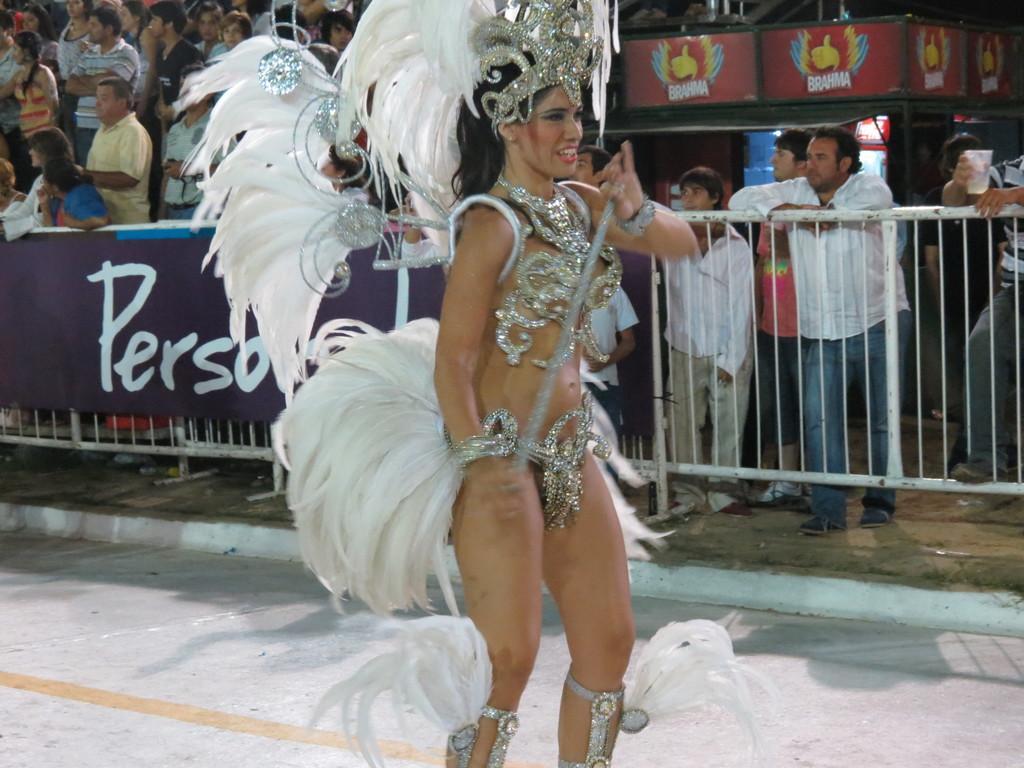In one or two sentences, can you explain what this image depicts? In this image I can see the person standing and the person is wearing white color dress. In the background I can see the board attached to the railing and I can see group of people standing. 